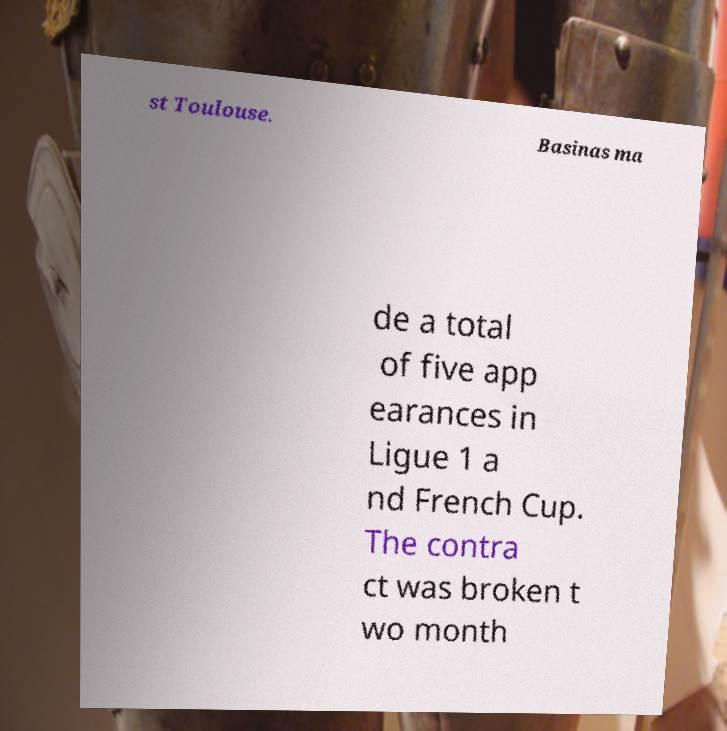Can you read and provide the text displayed in the image?This photo seems to have some interesting text. Can you extract and type it out for me? st Toulouse. Basinas ma de a total of five app earances in Ligue 1 a nd French Cup. The contra ct was broken t wo month 